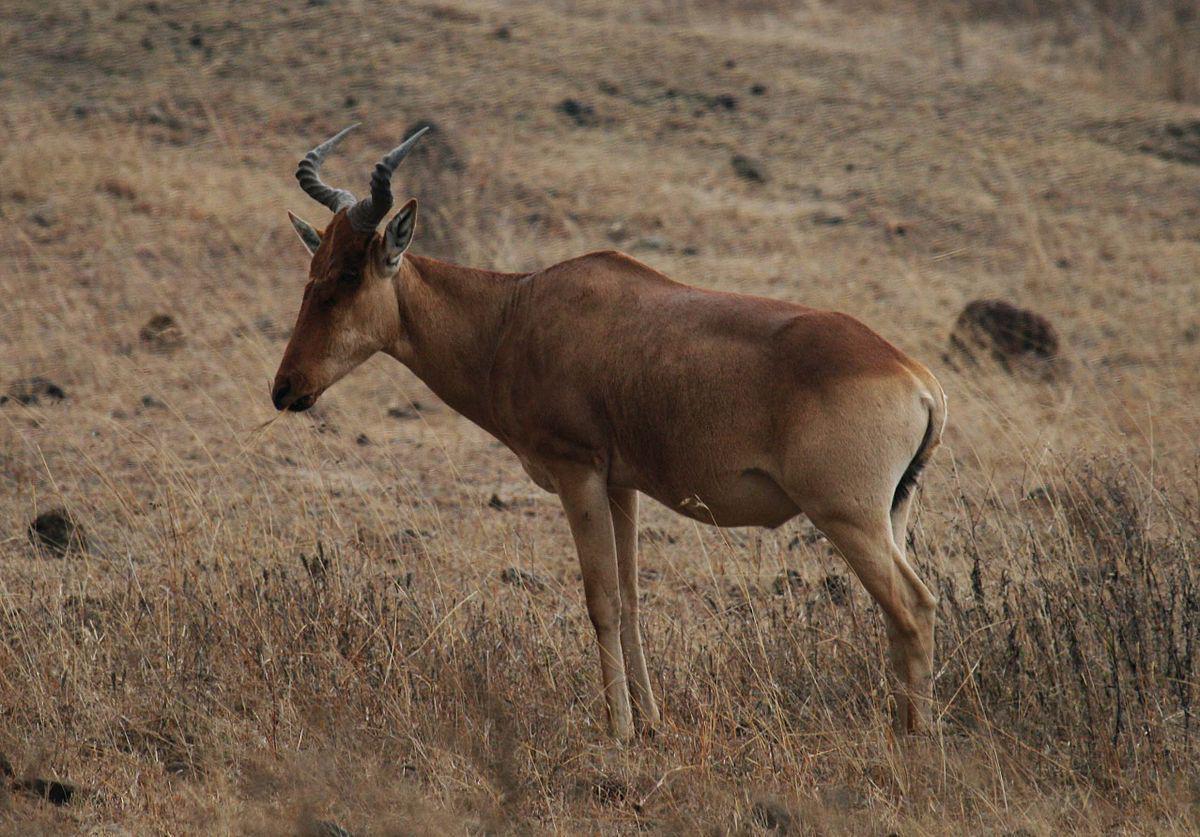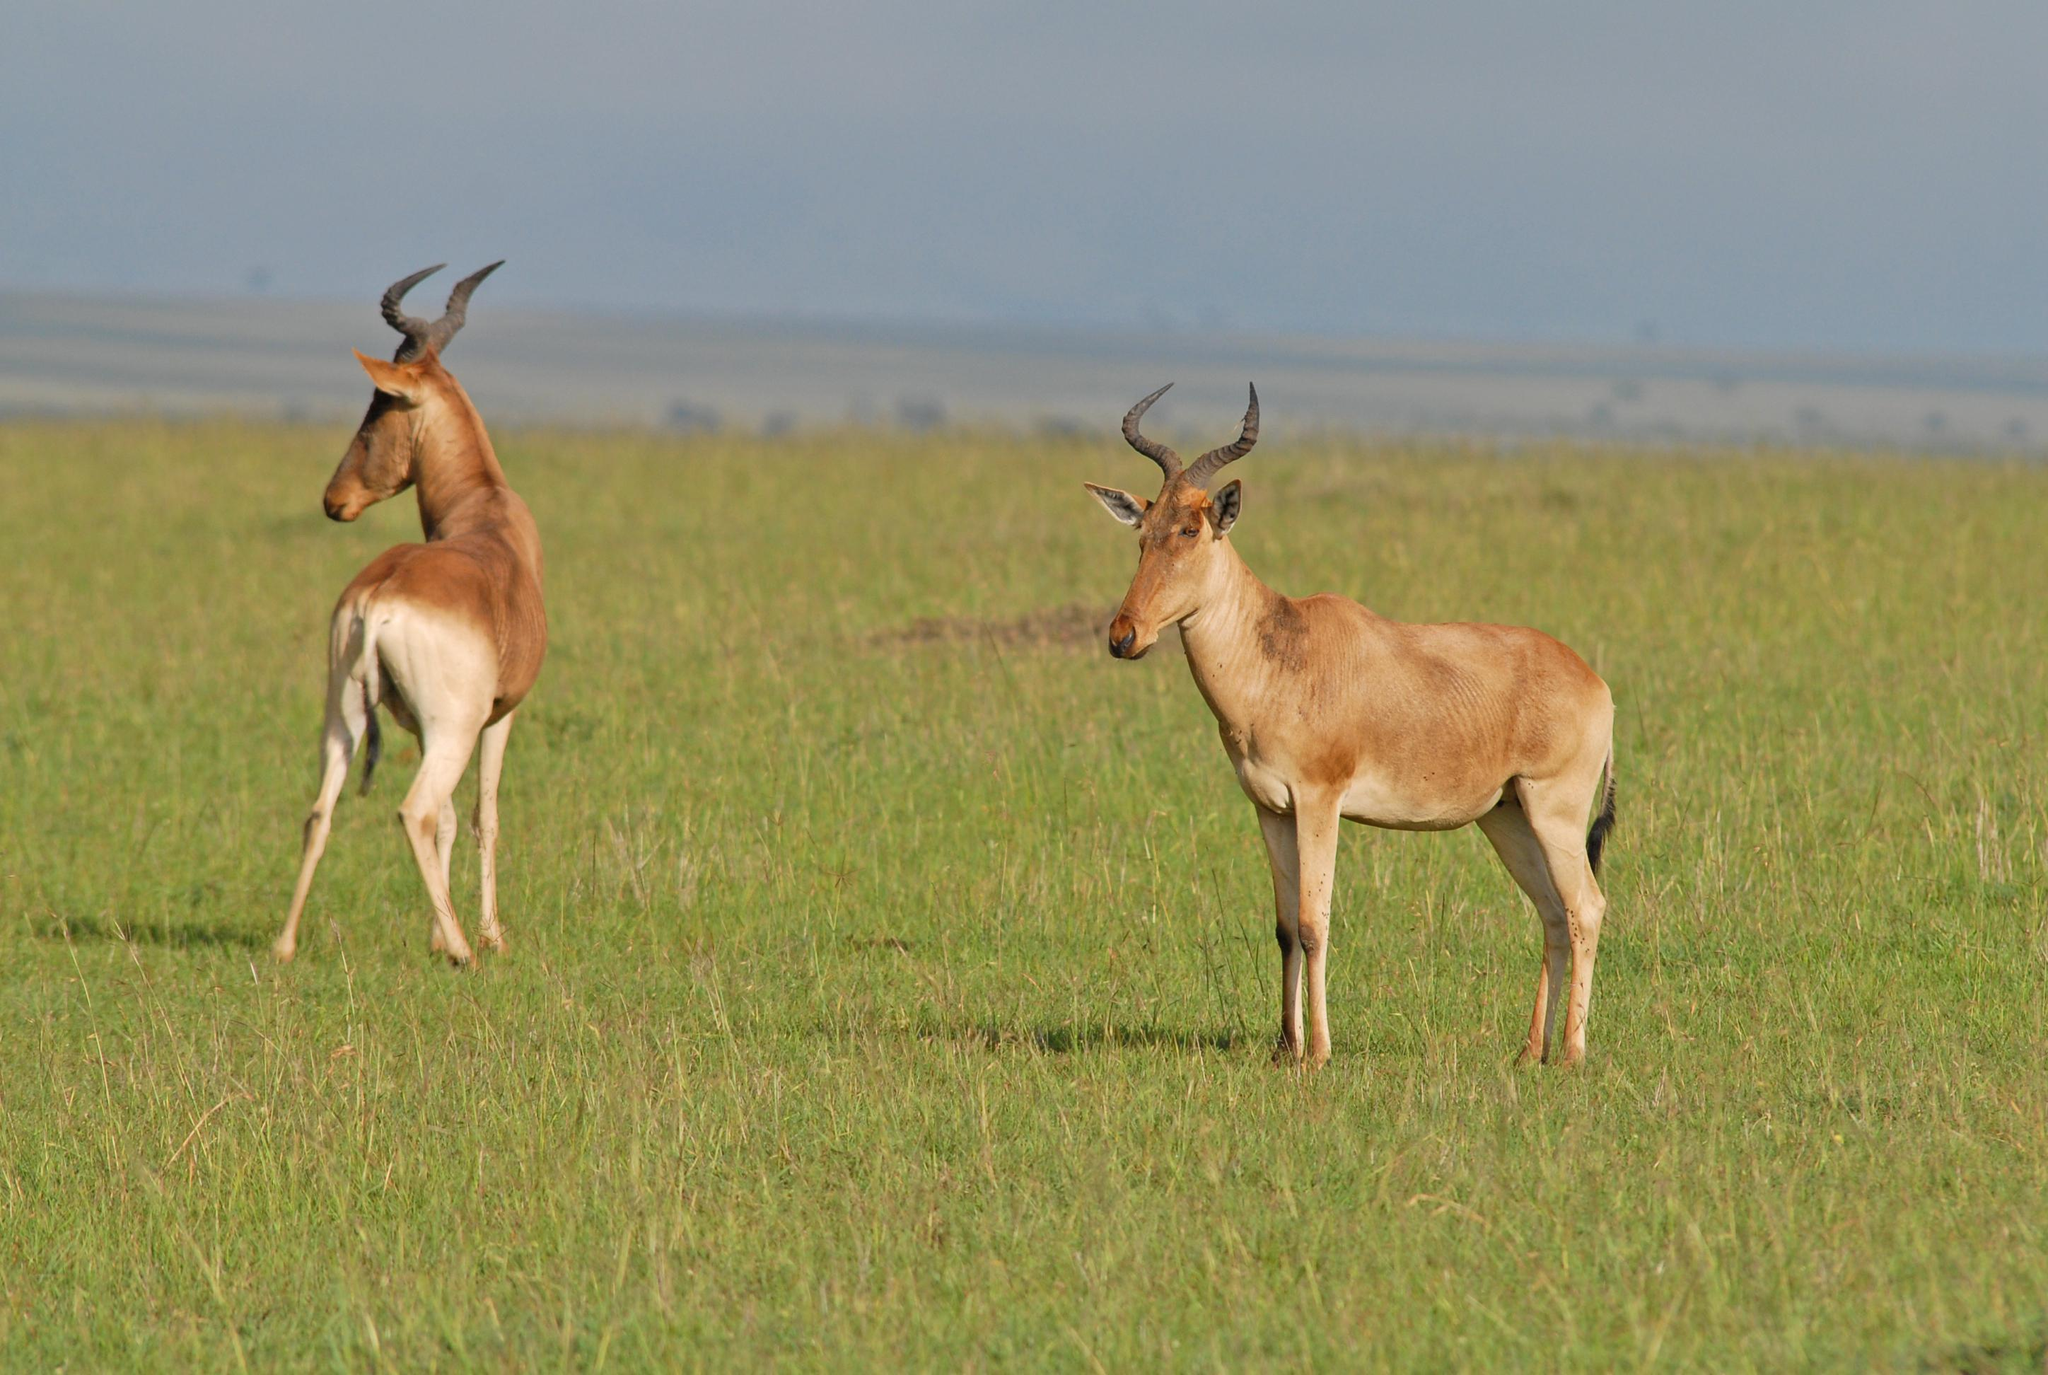The first image is the image on the left, the second image is the image on the right. Considering the images on both sides, is "An image shows just one horned animal, standing with its head in profile." valid? Answer yes or no. Yes. The first image is the image on the left, the second image is the image on the right. For the images displayed, is the sentence "The two images contain a total of three animals." factually correct? Answer yes or no. Yes. 